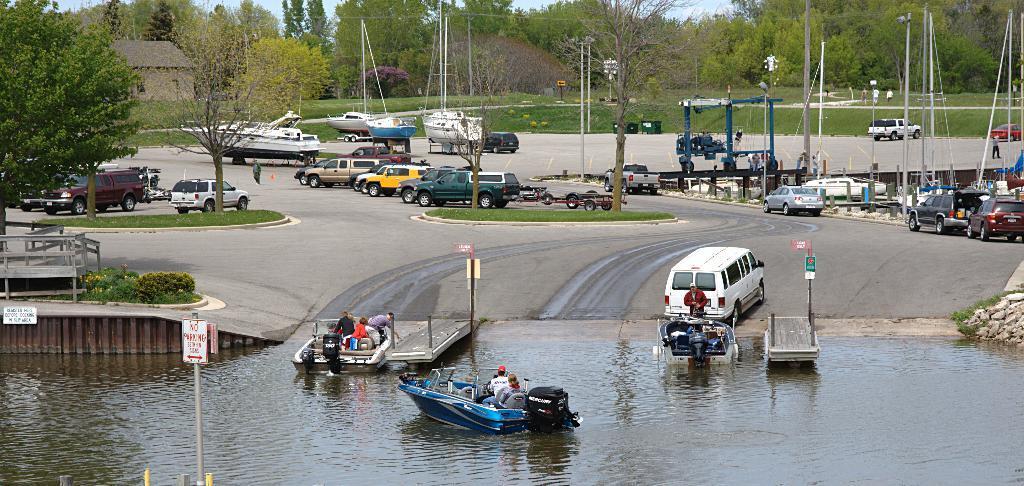Can you describe this image briefly? In this image we can see there are vehicles on the road and there are people sitting on the boat. And there are trees, plants, water, current polls, boards, grass, fence, house and the sky. 